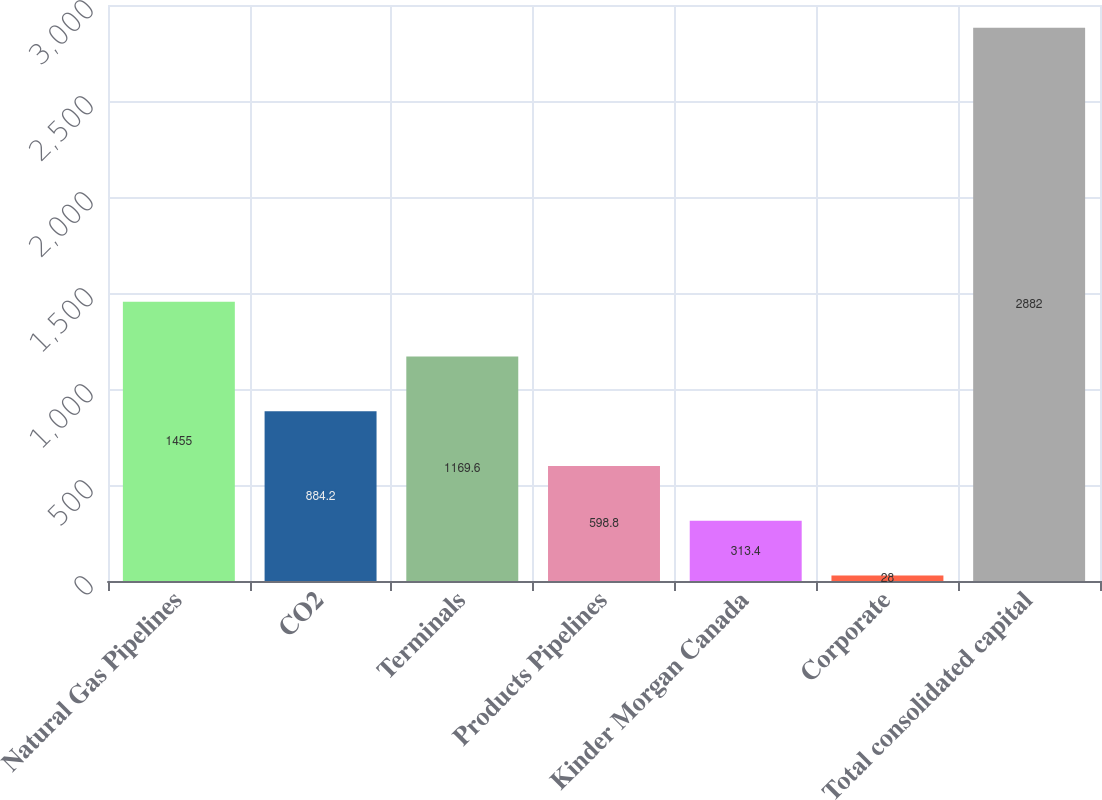<chart> <loc_0><loc_0><loc_500><loc_500><bar_chart><fcel>Natural Gas Pipelines<fcel>CO2<fcel>Terminals<fcel>Products Pipelines<fcel>Kinder Morgan Canada<fcel>Corporate<fcel>Total consolidated capital<nl><fcel>1455<fcel>884.2<fcel>1169.6<fcel>598.8<fcel>313.4<fcel>28<fcel>2882<nl></chart> 